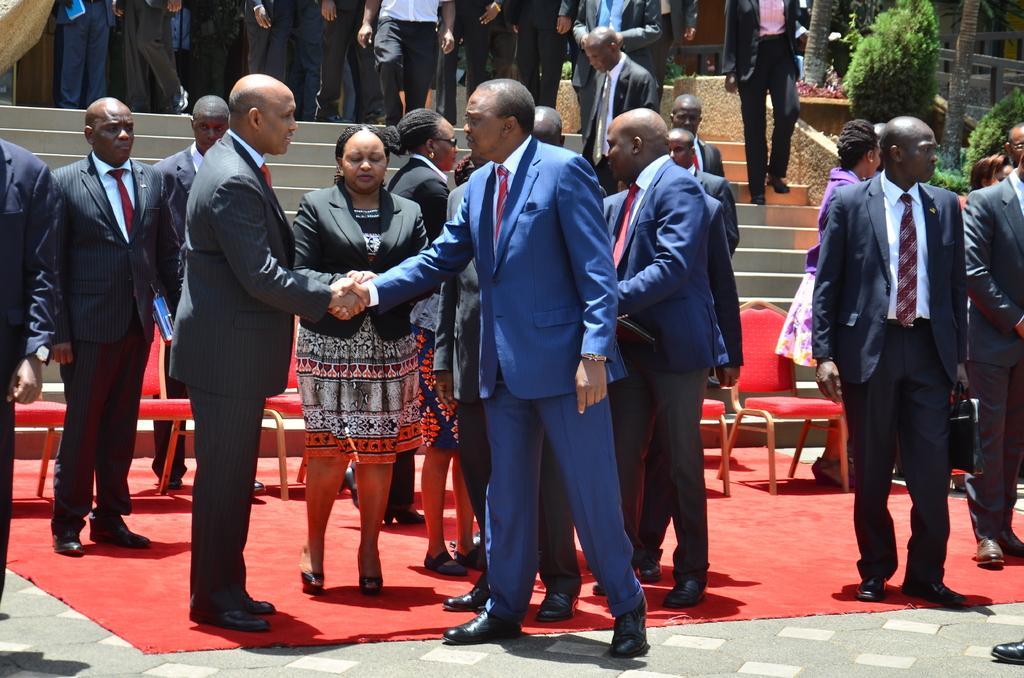Please provide a concise description of this image. In this image we can see a group of people. Here we can see two men shaking their hands and they are having the conversation. Here we can see a few people wearing a suit and a tie. Here we can see the wooden chairs on the red carpet. Here we can see a few people walking on the staircase. Here we can see the plants on the right side. 